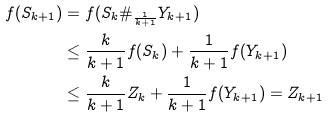<formula> <loc_0><loc_0><loc_500><loc_500>f ( S _ { k + 1 } ) & = f ( S _ { k } \# _ { \frac { 1 } { k + 1 } } Y _ { k + 1 } ) \\ & \leq \frac { k } { k + 1 } f ( S _ { k } ) + \frac { 1 } { k + 1 } f ( Y _ { k + 1 } ) \\ & \leq \frac { k } { k + 1 } Z _ { k } + \frac { 1 } { k + 1 } f ( Y _ { k + 1 } ) = Z _ { k + 1 }</formula> 